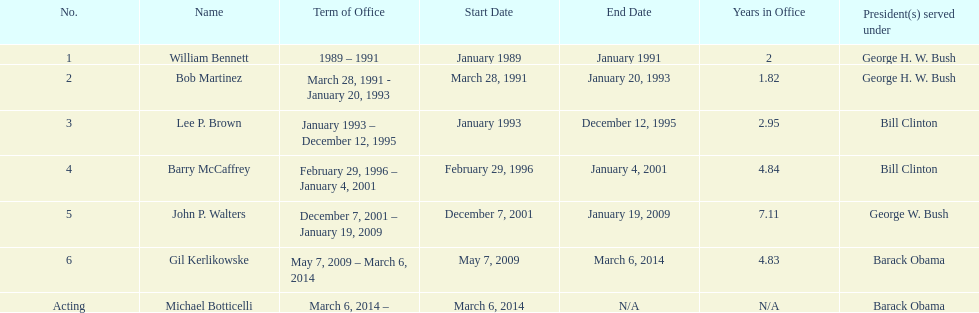How long did the first director serve in office? 2 years. 